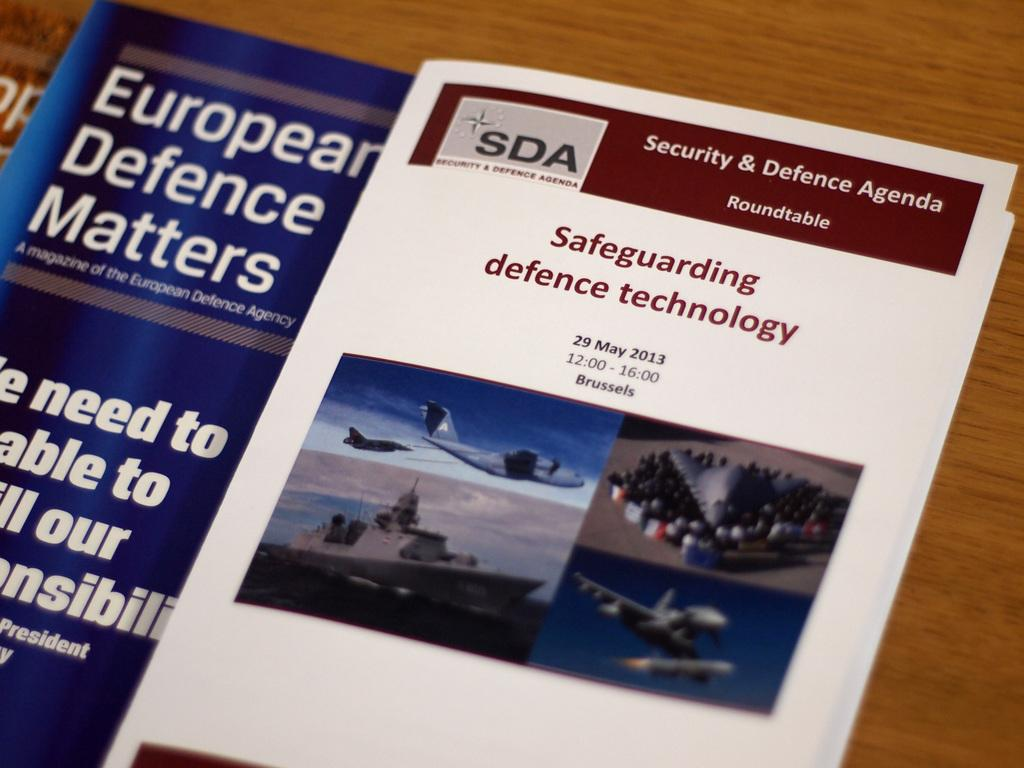<image>
Provide a brief description of the given image. Security & Defence Agenda and Safeguarding Defence Technology book that is good. 